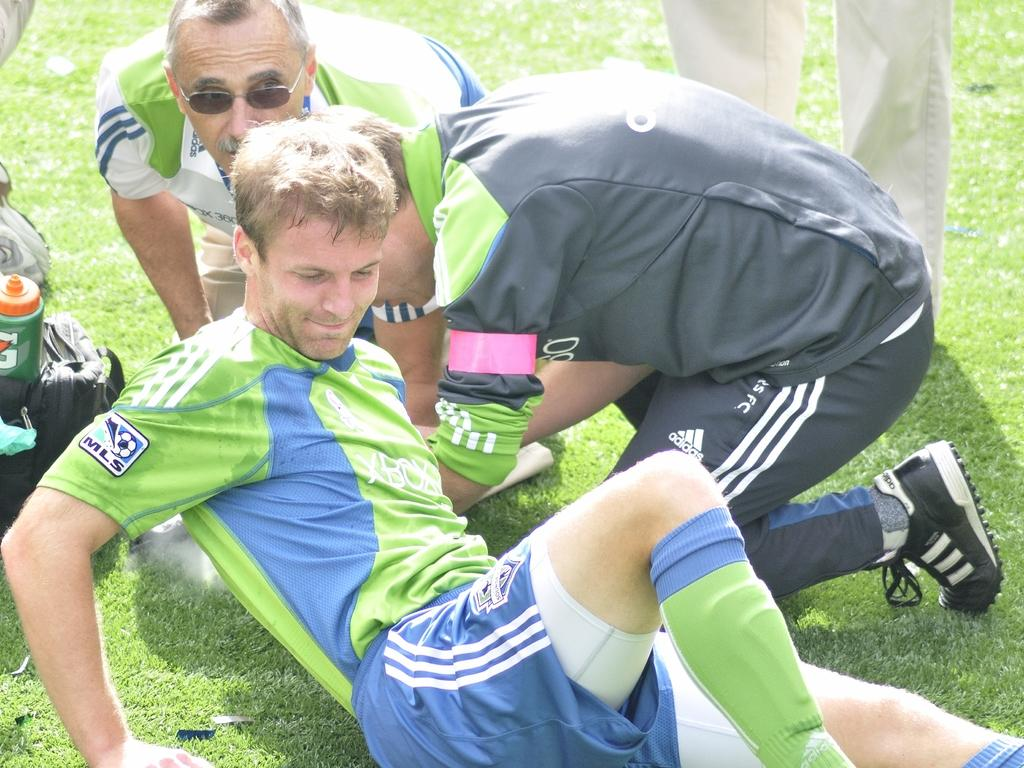What are the people in the image doing? There are persons sitting and standing in the image. Can you describe any objects in the image? There is a bag in the image, and a bottle is on the bag. What can be seen in the background of the image? There is grass in the background of the image. What type of flag is visible on the van in the image? There is no van or flag present in the image. What kind of vessel is being used by the people in the image? The image does not show any vessels being used by the people. 